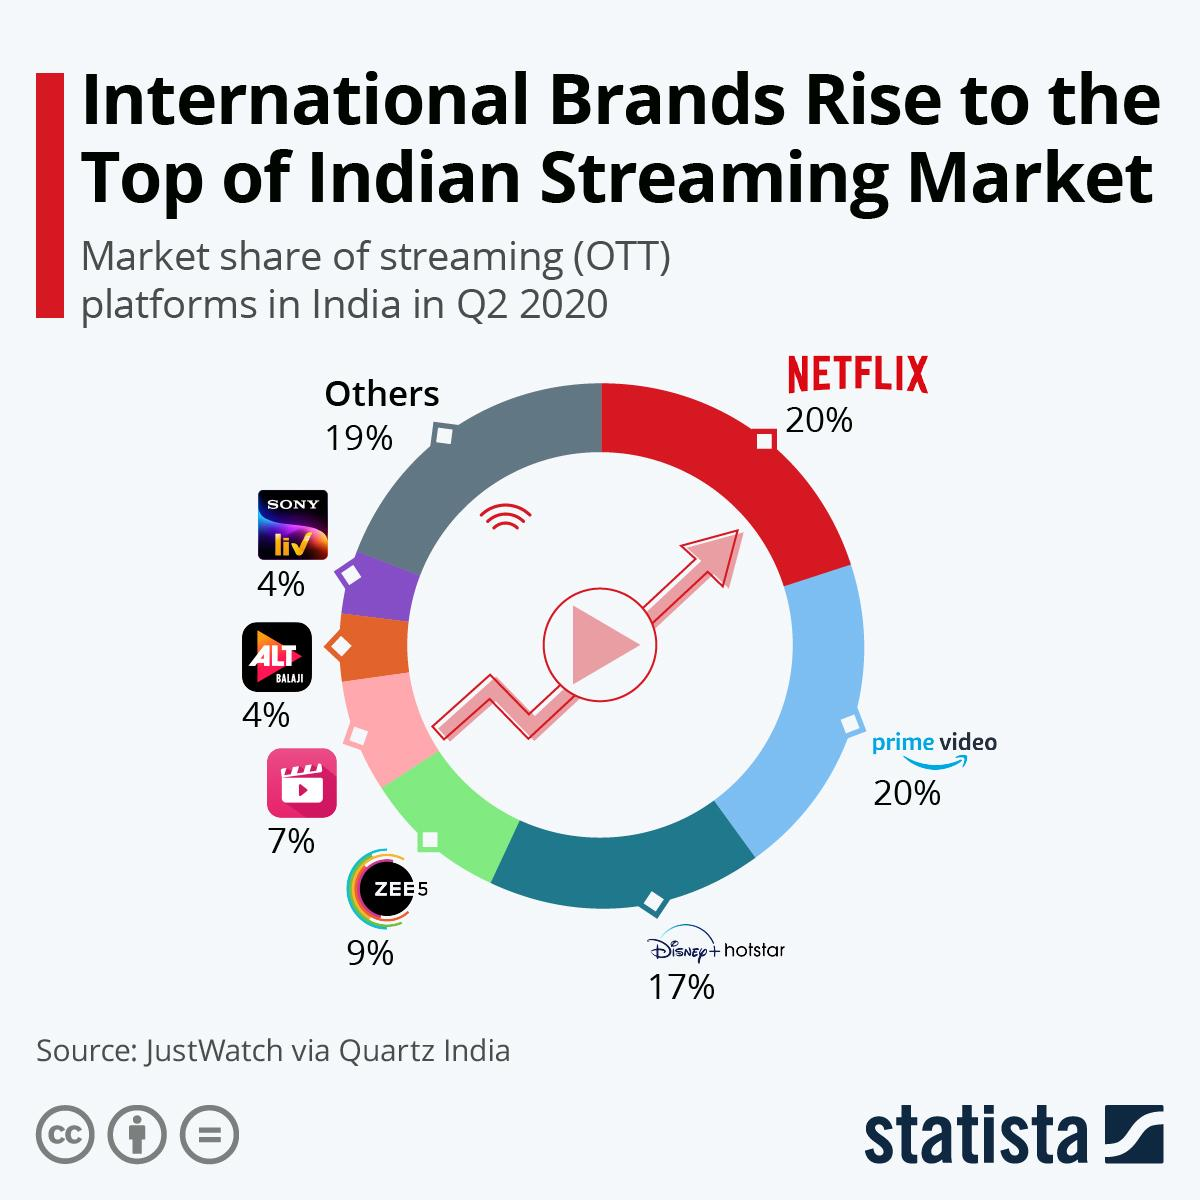Indicate a few pertinent items in this graphic. According to the data collected in Q2 2020, Netflix has the highest market share among all OTT platforms in India. According to the data for Q2 2020, the market share of ZEE5 in India was 9%. According to the latest data from Q2 2020, the second most popular OTT platform in India is Prime Video. According to data released in Q2 2020, Disney+ Hotstar accounted for 17% of the market share in India. 